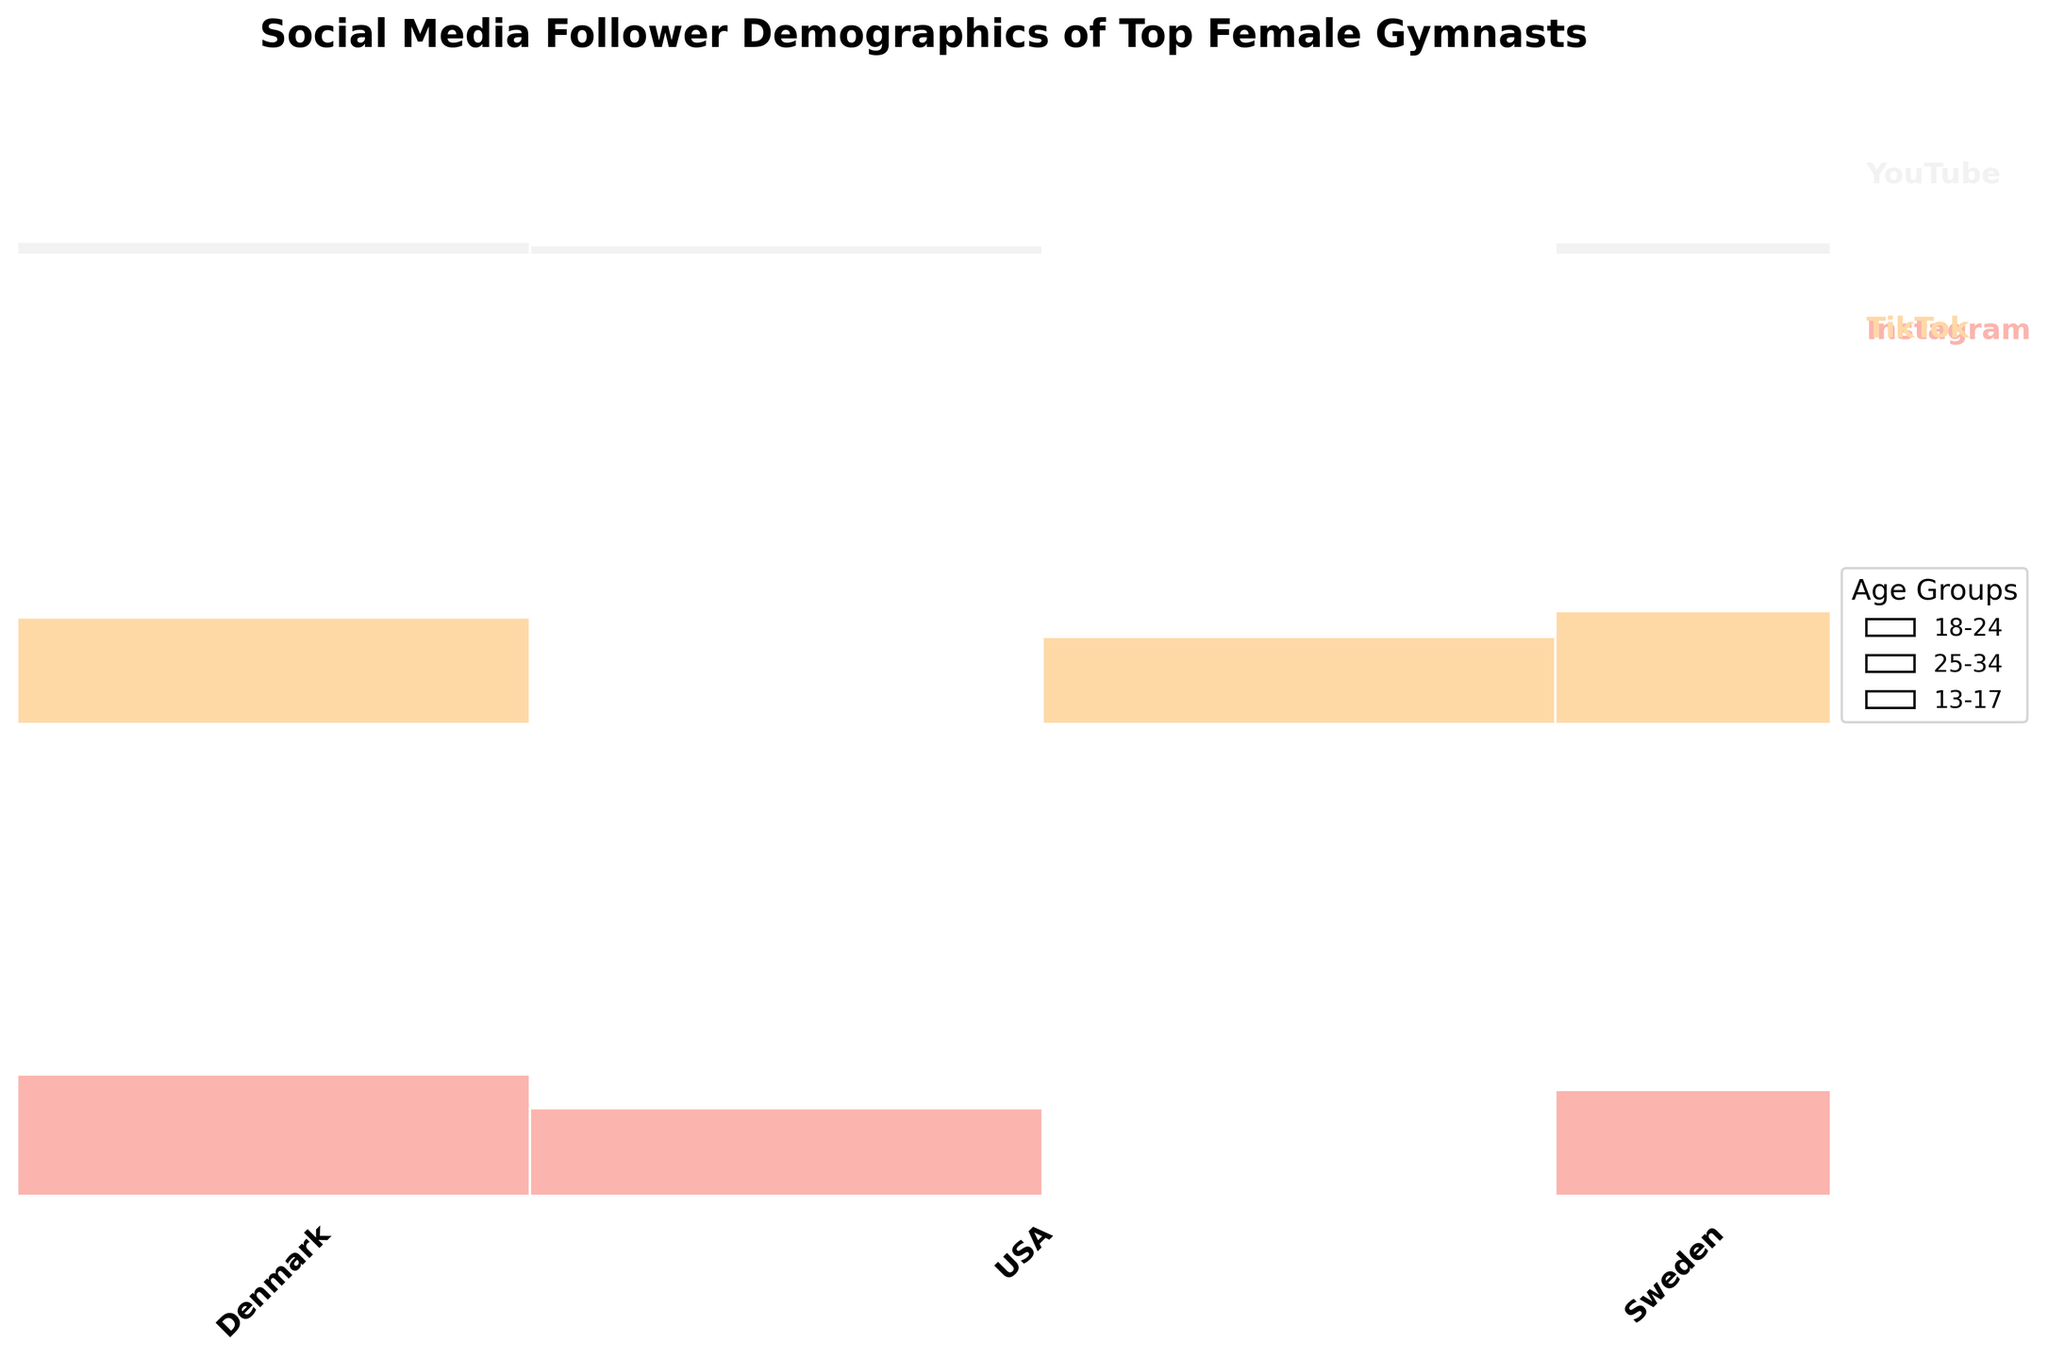What social media platform has the largest proportion of followers overall? To determine this, look at the height of the rectangles corresponding to each platform. The taller the rectangle, the larger the proportion of followers that platform has compared to others.
Answer: Instagram How many countries are represented in the mosaic plot? Count the distinct country names on the x-axis of the mosaic plot to find the total number.
Answer: 3 Which age group has the highest number of followers specifically on YouTube in the USA? Look at the portion of the plot corresponding to "YouTube" and "USA". Then, compare the sizes of rectangles representing different age groups within this section.
Answer: 18-24 Which social media platform has the fewest followers from Sweden in the 25-34 age group? Identify the sections related to each platform for Sweden. Compare the size of the rectangles corresponding to the 25-34 age group within each platform's total.
Answer: YouTube Are there more followers on Instagram or TikTok from Denmark aged 18-24? Compare the size of the rectangles corresponding to Instagram and TikTok for Denmark, focusing on the 18-24 age group specifically.
Answer: Instagram What is the total proportion of followers from the USA across all platforms? Sum the widths of the rectangles for the USA across all platforms on the x-axis. This represents the USA's total proportion of followers.
Answer: Approximately 50% Which country has the fewest TikTok followers in the 13-17 age group? Look at the segments corresponding to TikTok and compare the sizes of the rectangles for the 13-17 age group among all countries.
Answer: Sweden In which age group does Denmark have the smallest proportion of followers on Instagram? Within the Denmark Instagram section, compare the sizes of the rectangles for each age group. The smallest rectangle represents the smallest proportion.
Answer: 25-34 What’s the difference in follower proportion between the 18-24 and 25-34 age groups on Instagram in the USA? Within the Instagram section for the USA, subtract the proportion of the 25-34 group from that of the 18-24 group to find the difference.
Answer: 7% Which social media platform has the highest proportion of younger followers (13-17 age group) in the USA? Compare the heights of the sections representing the 13-17 age group within each platform for the USA.
Answer: TikTok 